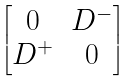Convert formula to latex. <formula><loc_0><loc_0><loc_500><loc_500>\begin{bmatrix} 0 & D ^ { - } \\ D ^ { + } & 0 \end{bmatrix}</formula> 